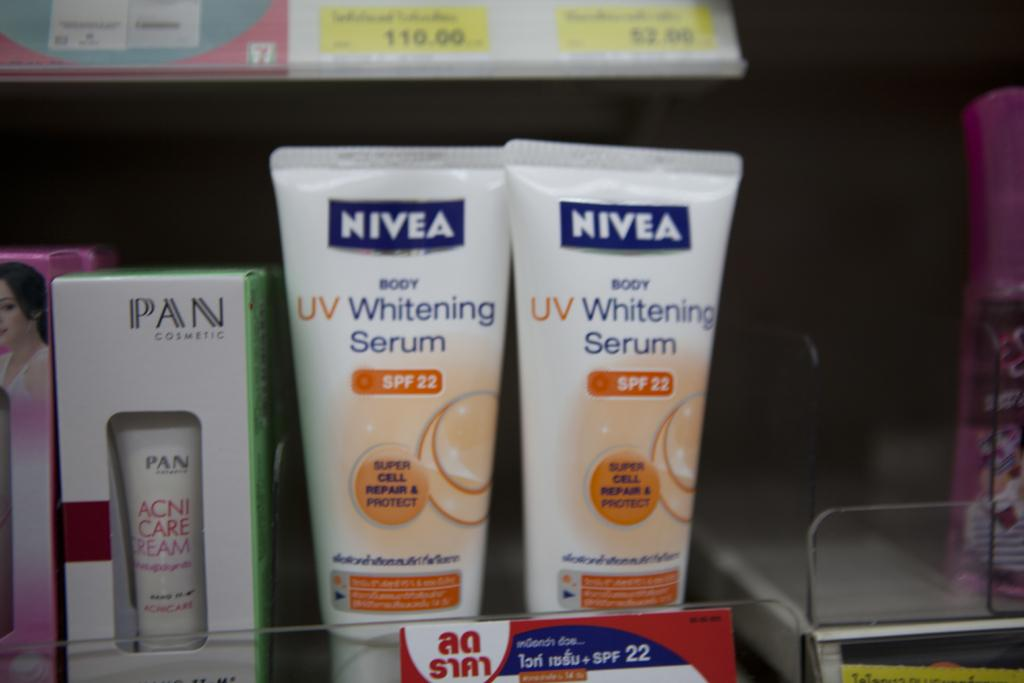<image>
Give a short and clear explanation of the subsequent image. NIVEA UV Whitening Serum is printed on the front of these bottles. 